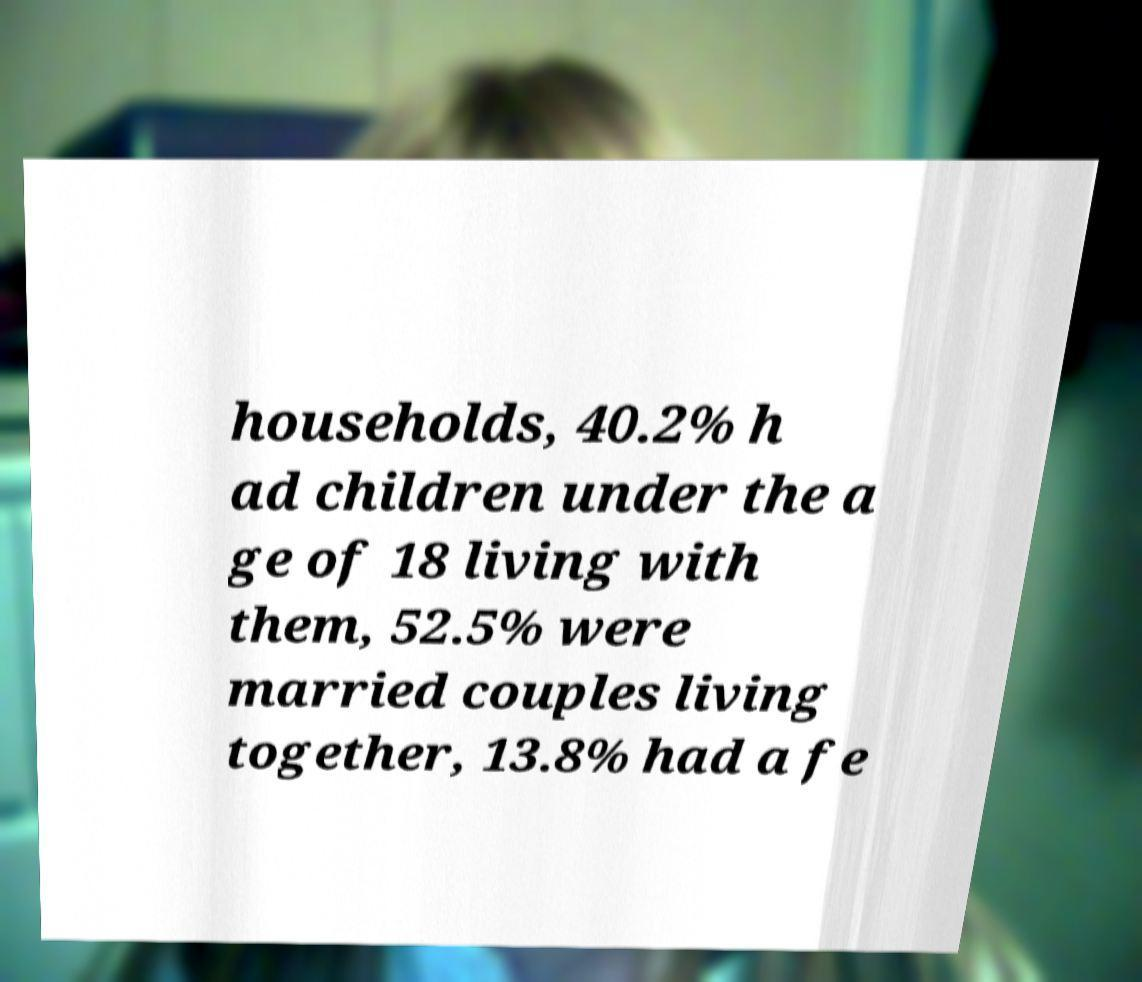There's text embedded in this image that I need extracted. Can you transcribe it verbatim? households, 40.2% h ad children under the a ge of 18 living with them, 52.5% were married couples living together, 13.8% had a fe 